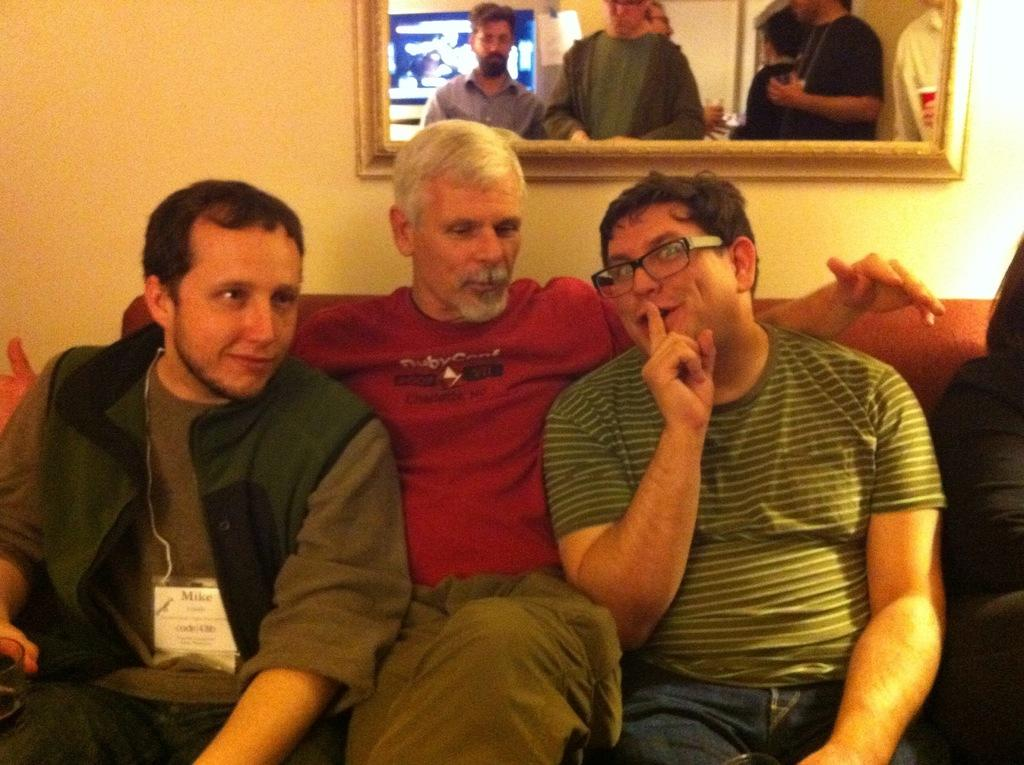How many people are sitting on the sofa in the image? There are three people sitting on the sofa in the image. Can you describe the gender of one of the people on the sofa? One of the people on the sofa is a man. What is the man wearing in the image? The man is wearing spectacles. What can be seen in the background of the image? There are people visible in the background, and there is a wall in the background. What type of twig is being used to pull the sofa in the image? There is no twig or any indication of the sofa being moved in the image. How many bananas are being eaten by the people in the image? There are no bananas visible in the image. 